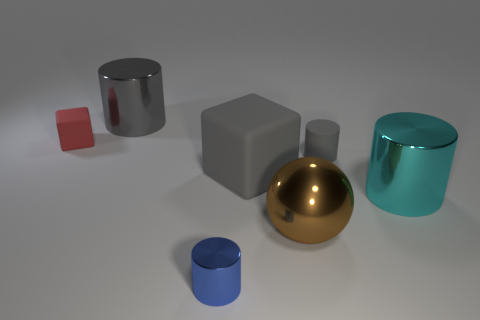What number of other things are the same shape as the brown object?
Offer a very short reply. 0. There is another cylinder that is the same size as the gray rubber cylinder; what color is it?
Give a very brief answer. Blue. What is the color of the tiny object in front of the big cyan cylinder?
Your answer should be very brief. Blue. There is a cube that is to the right of the tiny red block; are there any big cyan cylinders behind it?
Provide a short and direct response. No. There is a brown metallic thing; does it have the same shape as the large object on the right side of the big brown metal thing?
Offer a very short reply. No. What size is the object that is both in front of the big gray matte object and to the right of the sphere?
Your answer should be compact. Large. Is there a gray cylinder that has the same material as the gray block?
Your answer should be very brief. Yes. What is the size of the cube that is the same color as the tiny rubber cylinder?
Provide a short and direct response. Large. What is the big cylinder right of the tiny object that is in front of the brown shiny object made of?
Provide a short and direct response. Metal. What number of metal things are the same color as the large matte cube?
Make the answer very short. 1. 